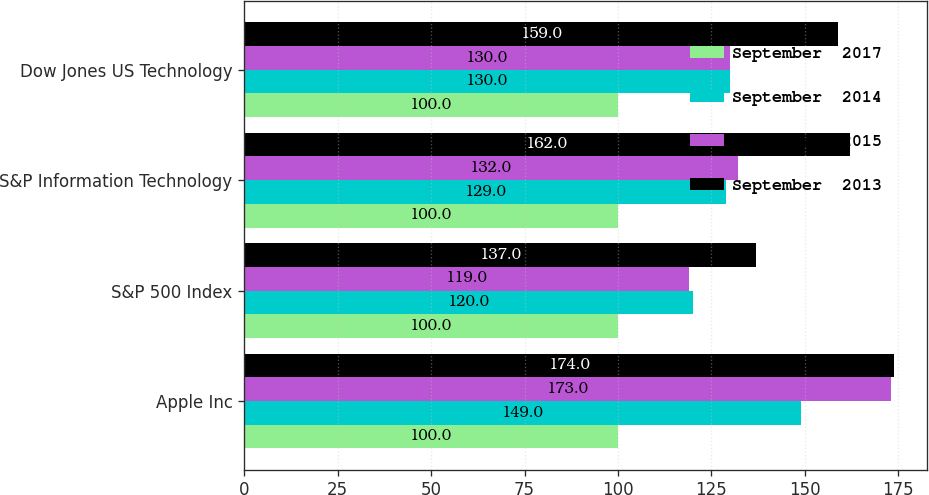Convert chart to OTSL. <chart><loc_0><loc_0><loc_500><loc_500><stacked_bar_chart><ecel><fcel>Apple Inc<fcel>S&P 500 Index<fcel>S&P Information Technology<fcel>Dow Jones US Technology<nl><fcel>September  2017<fcel>100<fcel>100<fcel>100<fcel>100<nl><fcel>September  2014<fcel>149<fcel>120<fcel>129<fcel>130<nl><fcel>September  2015<fcel>173<fcel>119<fcel>132<fcel>130<nl><fcel>September  2013<fcel>174<fcel>137<fcel>162<fcel>159<nl></chart> 